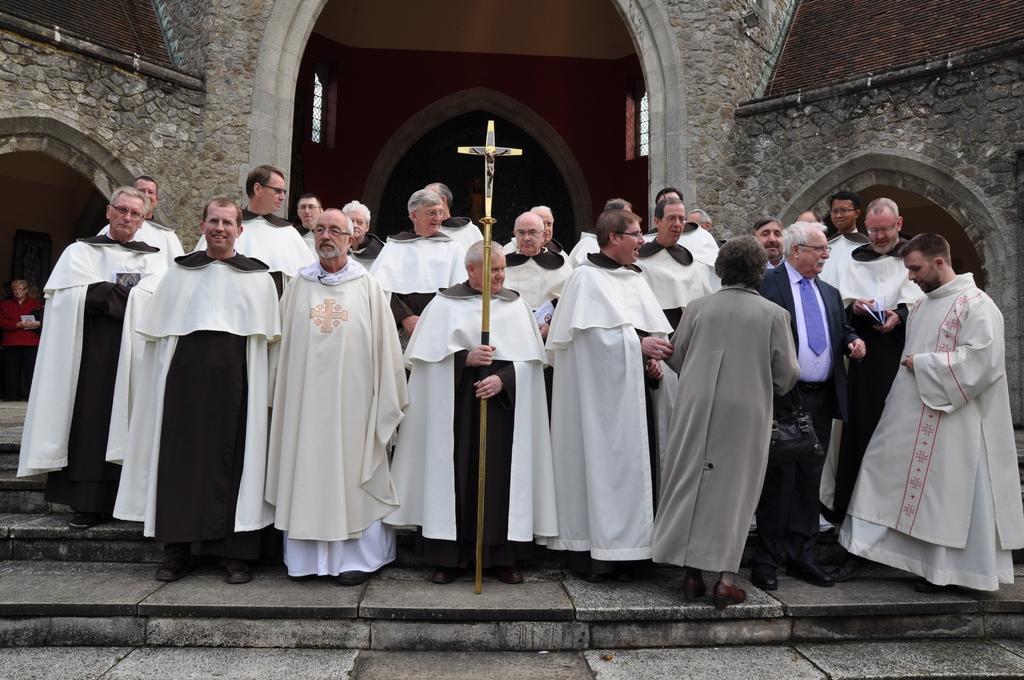Describe this image in one or two sentences. In the center of the image we can see a group of people are standing. In the middle of the image a man is standing and holding an object. In the background of the image we can see building, door, windows, wall are present. At the bottom of the image stairs are there. 